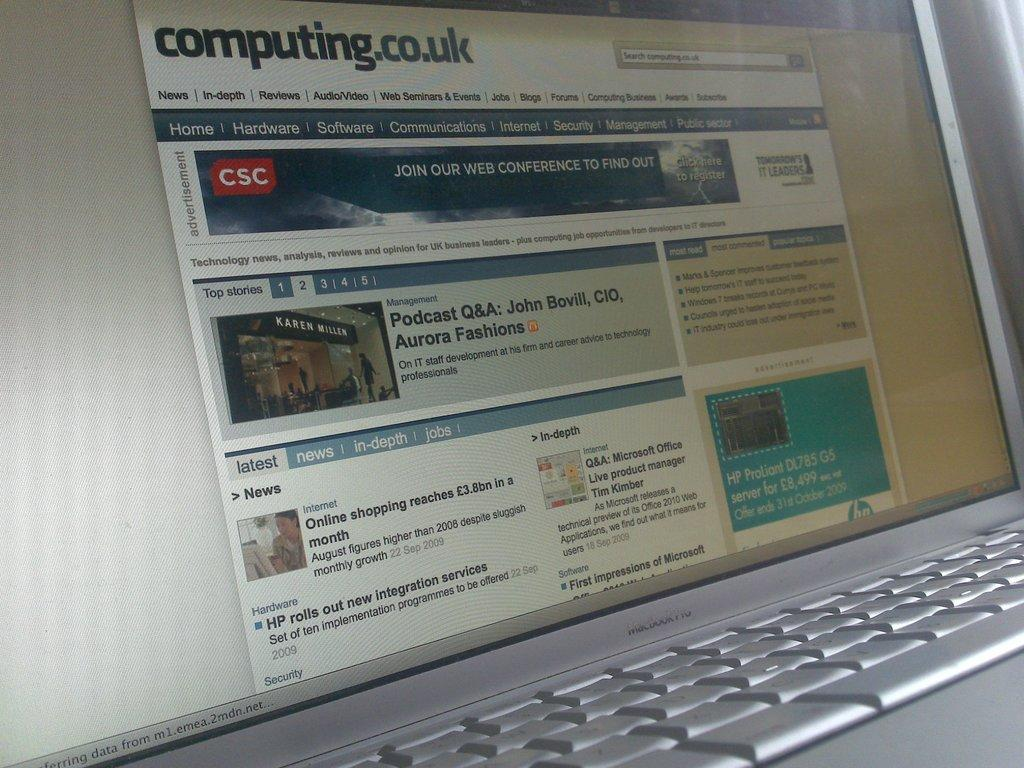Provide a one-sentence caption for the provided image. An open laptop is open to a computing.co.uk webpage. 